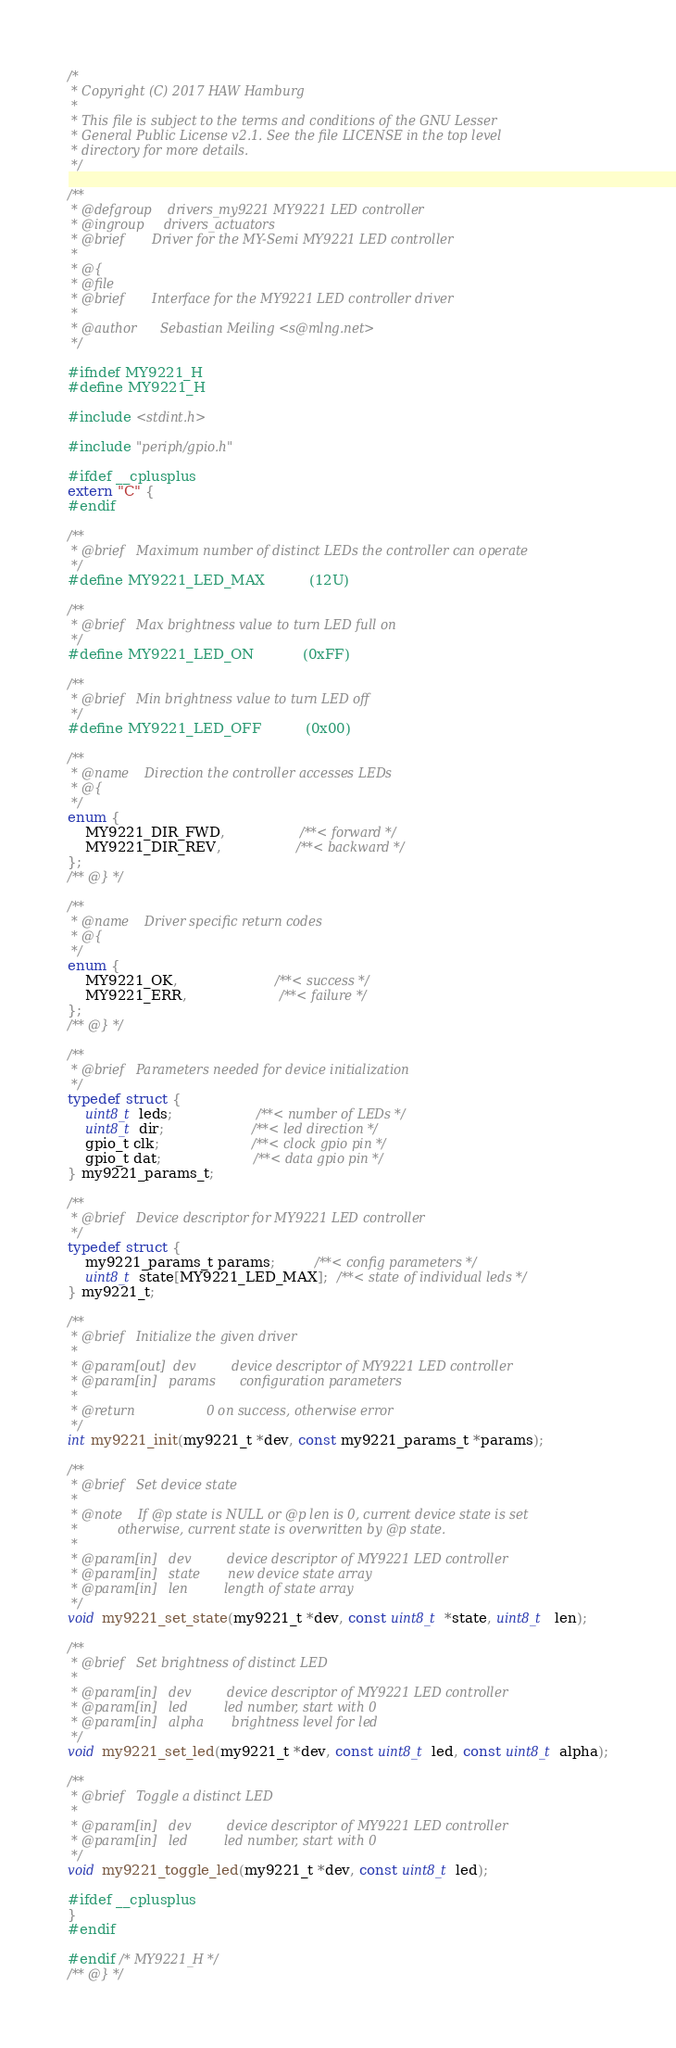<code> <loc_0><loc_0><loc_500><loc_500><_C_>/*
 * Copyright (C) 2017 HAW Hamburg
 *
 * This file is subject to the terms and conditions of the GNU Lesser
 * General Public License v2.1. See the file LICENSE in the top level
 * directory for more details.
 */

/**
 * @defgroup    drivers_my9221 MY9221 LED controller
 * @ingroup     drivers_actuators
 * @brief       Driver for the MY-Semi MY9221 LED controller
 *
 * @{
 * @file
 * @brief       Interface for the MY9221 LED controller driver
 *
 * @author      Sebastian Meiling <s@mlng.net>
 */

#ifndef MY9221_H
#define MY9221_H

#include <stdint.h>

#include "periph/gpio.h"

#ifdef __cplusplus
extern "C" {
#endif

/**
 * @brief   Maximum number of distinct LEDs the controller can operate
 */
#define MY9221_LED_MAX          (12U)

/**
 * @brief   Max brightness value to turn LED full on
 */
#define MY9221_LED_ON           (0xFF)

/**
 * @brief   Min brightness value to turn LED off
 */
#define MY9221_LED_OFF          (0x00)

/**
 * @name    Direction the controller accesses LEDs
 * @{
 */
enum {
    MY9221_DIR_FWD,                 /**< forward */
    MY9221_DIR_REV,                 /**< backward */
};
/** @} */

/**
 * @name    Driver specific return codes
 * @{
 */
enum {
    MY9221_OK,                      /**< success */
    MY9221_ERR,                     /**< failure */
};
/** @} */

/**
 * @brief   Parameters needed for device initialization
 */
typedef struct {
    uint8_t leds;                   /**< number of LEDs */
    uint8_t dir;                    /**< led direction */
    gpio_t clk;                     /**< clock gpio pin */
    gpio_t dat;                     /**< data gpio pin */
} my9221_params_t;

/**
 * @brief   Device descriptor for MY9221 LED controller
 */
typedef struct {
    my9221_params_t params;         /**< config parameters */
    uint8_t state[MY9221_LED_MAX];  /**< state of individual leds */
} my9221_t;

/**
 * @brief   Initialize the given driver
 *
 * @param[out]  dev         device descriptor of MY9221 LED controller
 * @param[in]   params      configuration parameters
 *
 * @return                  0 on success, otherwise error
 */
int my9221_init(my9221_t *dev, const my9221_params_t *params);

/**
 * @brief   Set device state
 *
 * @note    If @p state is NULL or @p len is 0, current device state is set
 *          otherwise, current state is overwritten by @p state.
 *
 * @param[in]   dev         device descriptor of MY9221 LED controller
 * @param[in]   state       new device state array
 * @param[in]   len         length of state array
 */
void my9221_set_state(my9221_t *dev, const uint8_t *state, uint8_t  len);

/**
 * @brief   Set brightness of distinct LED
 *
 * @param[in]   dev         device descriptor of MY9221 LED controller
 * @param[in]   led         led number, start with 0
 * @param[in]   alpha       brightness level for led
 */
void my9221_set_led(my9221_t *dev, const uint8_t led, const uint8_t alpha);

/**
 * @brief   Toggle a distinct LED
 *
 * @param[in]   dev         device descriptor of MY9221 LED controller
 * @param[in]   led         led number, start with 0
 */
void my9221_toggle_led(my9221_t *dev, const uint8_t led);

#ifdef __cplusplus
}
#endif

#endif /* MY9221_H */
/** @} */
</code> 